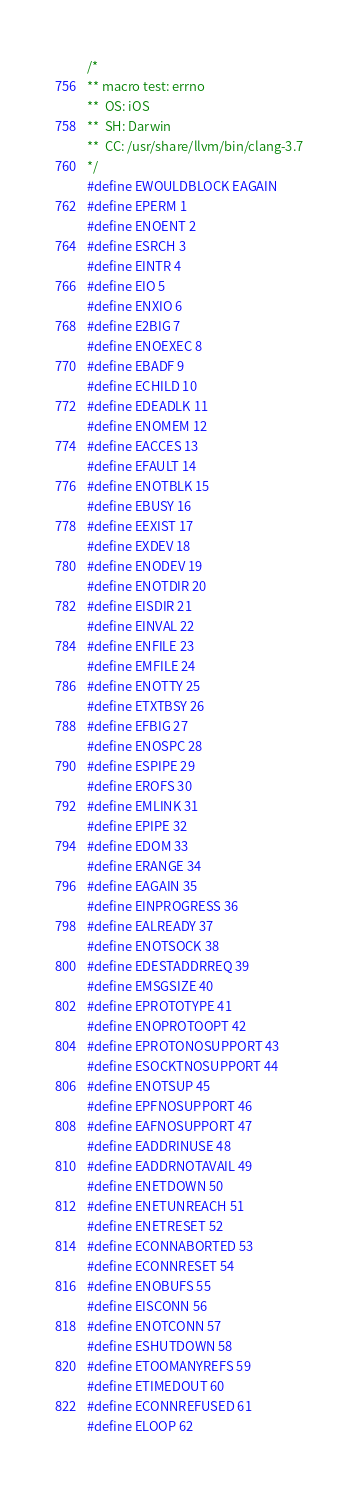<code> <loc_0><loc_0><loc_500><loc_500><_C_>/*
** macro test: errno
**	OS: iOS
**	SH: Darwin
**	CC: /usr/share/llvm/bin/clang-3.7
*/
#define EWOULDBLOCK EAGAIN
#define EPERM 1
#define ENOENT 2
#define ESRCH 3
#define EINTR 4
#define EIO 5
#define ENXIO 6
#define E2BIG 7
#define ENOEXEC 8
#define EBADF 9
#define ECHILD 10
#define EDEADLK 11
#define ENOMEM 12
#define EACCES 13
#define EFAULT 14
#define ENOTBLK 15
#define EBUSY 16
#define EEXIST 17
#define EXDEV 18
#define ENODEV 19
#define ENOTDIR 20
#define EISDIR 21
#define EINVAL 22
#define ENFILE 23
#define EMFILE 24
#define ENOTTY 25
#define ETXTBSY 26
#define EFBIG 27
#define ENOSPC 28
#define ESPIPE 29
#define EROFS 30
#define EMLINK 31
#define EPIPE 32
#define EDOM 33
#define ERANGE 34
#define EAGAIN 35
#define EINPROGRESS 36
#define EALREADY 37
#define ENOTSOCK 38
#define EDESTADDRREQ 39
#define EMSGSIZE 40
#define EPROTOTYPE 41
#define ENOPROTOOPT 42
#define EPROTONOSUPPORT 43
#define ESOCKTNOSUPPORT 44
#define ENOTSUP 45
#define EPFNOSUPPORT 46
#define EAFNOSUPPORT 47
#define EADDRINUSE 48
#define EADDRNOTAVAIL 49
#define ENETDOWN 50
#define ENETUNREACH 51
#define ENETRESET 52
#define ECONNABORTED 53
#define ECONNRESET 54
#define ENOBUFS 55
#define EISCONN 56
#define ENOTCONN 57
#define ESHUTDOWN 58
#define ETOOMANYREFS 59
#define ETIMEDOUT 60
#define ECONNREFUSED 61
#define ELOOP 62</code> 